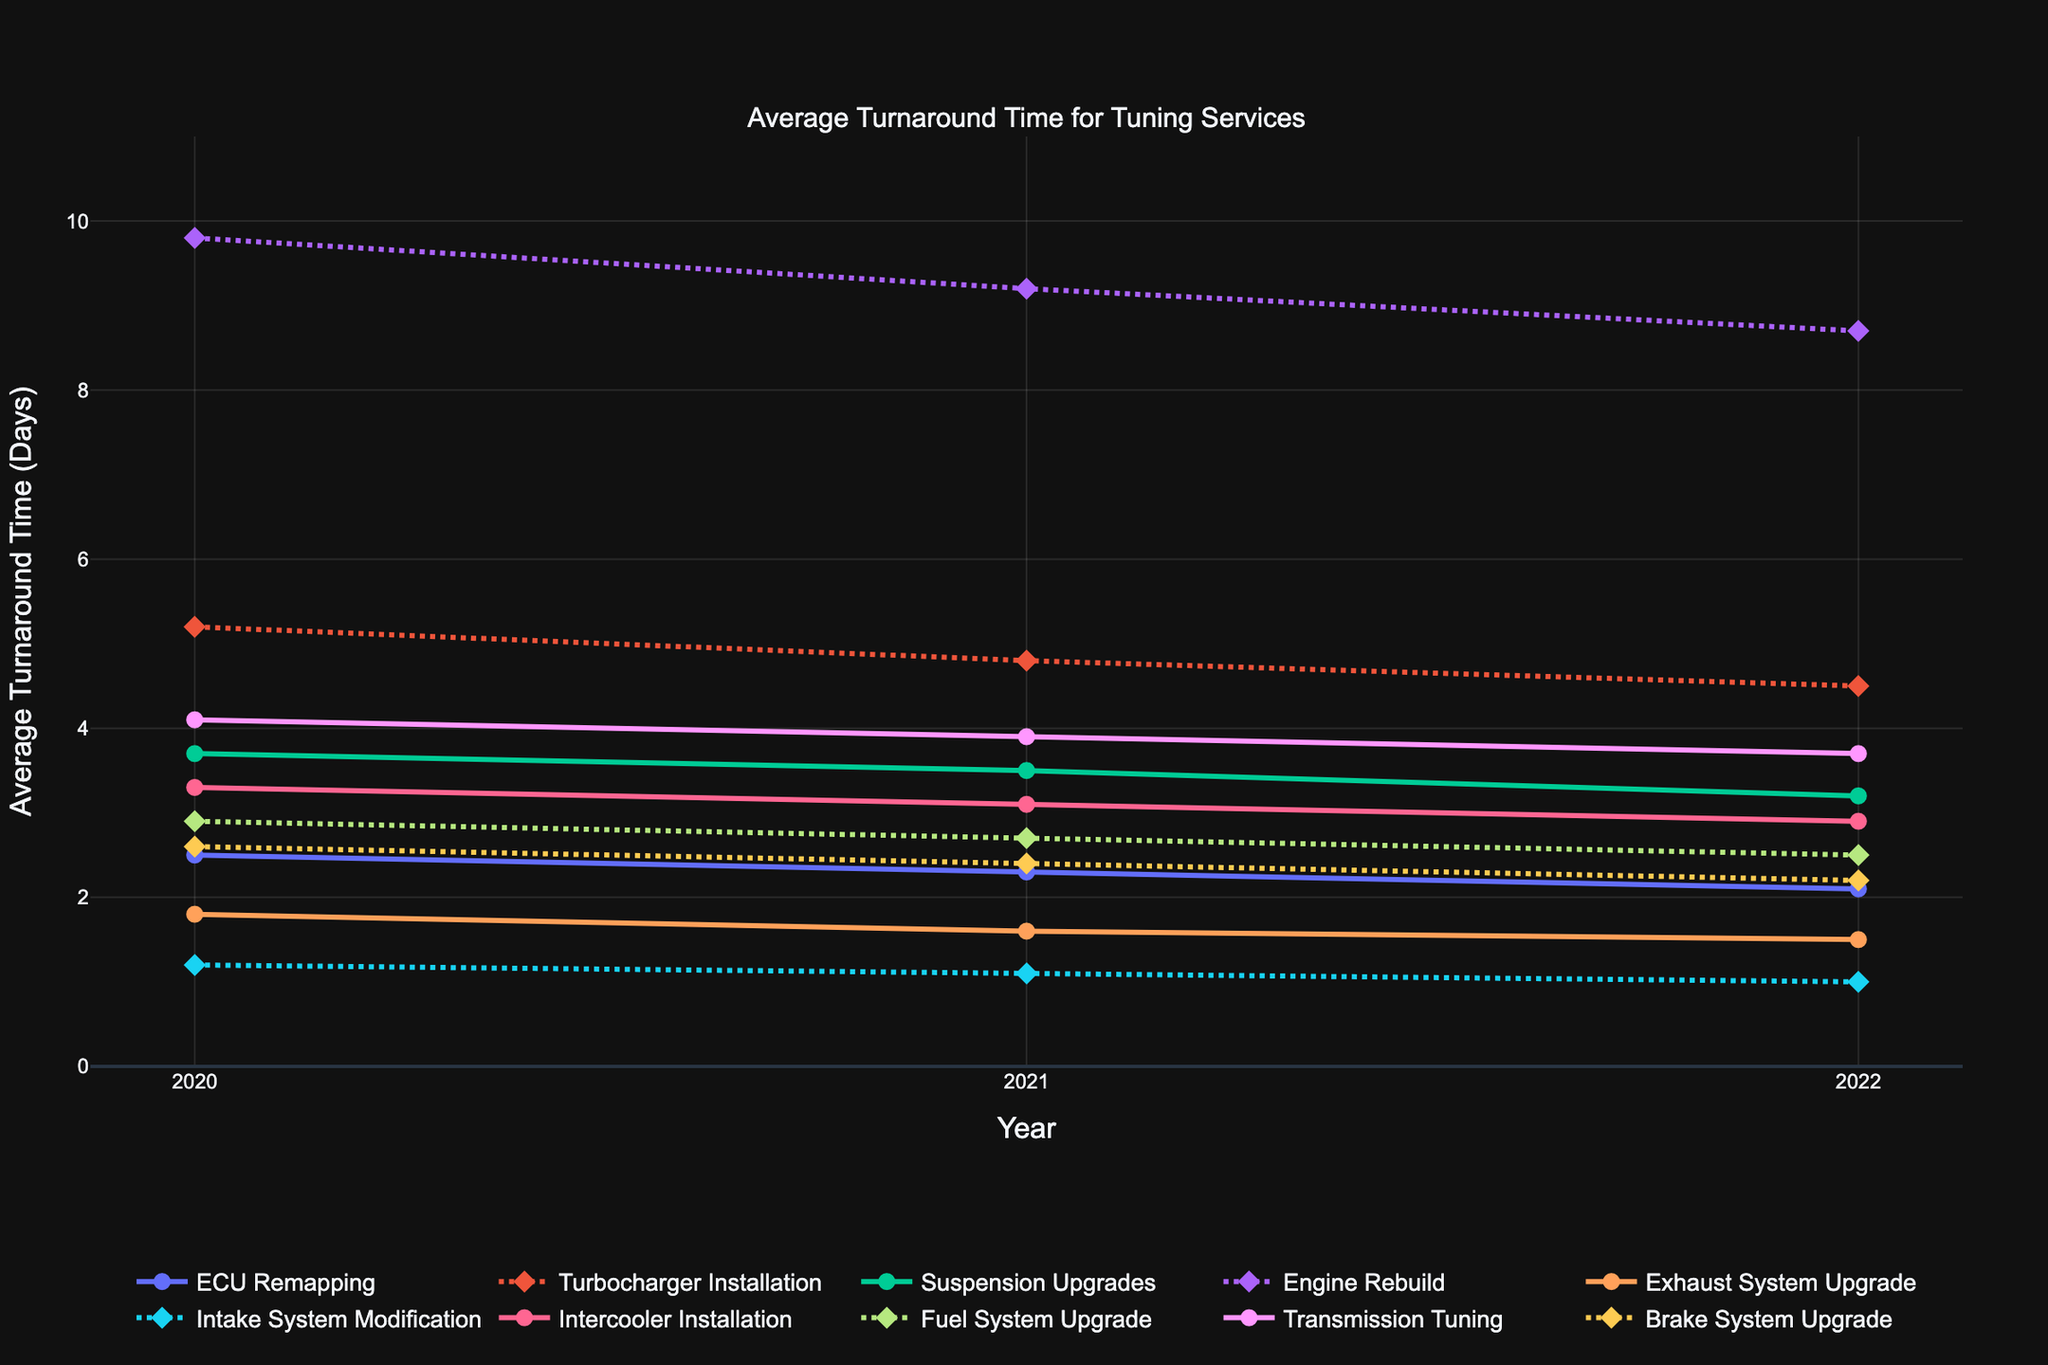Which service had the largest reduction in average turnaround time from 2020 to 2022? To find this, calculate the reduction for each service by subtracting the 2022 figure from the 2020 figure. Then, identify the largest value. For ECU Remapping, it is 2.5 - 2.1 = 0.4. For Turbocharger Installation, it is 5.2 - 4.5 = 0.7. For Suspension Upgrades, it is 3.7 - 3.2 = 0.5. For Engine Rebuild, it is 9.8 - 8.7 = 1.1. For Exhaust System Upgrade, it is 1.8 - 1.5 = 0.3. For Intake System Modification, it is 1.2 - 1.0 = 0.2. For Intercooler Installation, it is 3.3 - 2.9 = 0.4. For Fuel System Upgrade, it is 2.9 - 2.5 = 0.4. For Transmission Tuning, it is 4.1 - 3.7 = 0.4. For Brake System Upgrade, it is 2.6 - 2.2 = 0.4. So, the largest reduction is for Engine Rebuild (1.1).
Answer: Engine Rebuild Which service had the shortest average turnaround time in 2022? To answer this, look at the 2022 column and identify the smallest value. The values are: ECU Remapping (2.1), Turbocharger Installation (4.5), Suspension Upgrades (3.2), Engine Rebuild (8.7), Exhaust System Upgrade (1.5), Intake System Modification (1.0), Intercooler Installation (2.9), Fuel System Upgrade (2.5), Transmission Tuning (3.7), Brake System Upgrade (2.2). The smallest value is 1.0, corresponding to Intake System Modification.
Answer: Intake System Modification Which service shows a consistent yearly decrease in average turnaround time from 2020 to 2022? To determine this, check for each service whether the turnaround time decreases from 2020 to 2021 and again from 2021 to 2022. ECU Remapping: 2.5 -> 2.3 -> 2.1 (yes), Turbocharger Installation: 5.2 -> 4.8 -> 4.5 (yes), Suspension Upgrades: 3.7 -> 3.5 -> 3.2 (yes), Engine Rebuild: 9.8 -> 9.2 -> 8.7 (yes), Exhaust System Upgrade: 1.8 -> 1.6 -> 1.5 (yes), Intake System Modification: 1.2 -> 1.1 -> 1.0 (yes), Intercooler Installation: 3.3 -> 3.1 -> 2.9 (yes), Fuel System Upgrade: 2.9 -> 2.7 -> 2.5 (yes), Transmission Tuning: 4.1 -> 3.9 -> 3.7 (yes), Brake System Upgrade: 2.6 -> 2.4 -> 2.2 (yes). All services show a consistent decrease.
Answer: All services By how many days did the average turnaround time for Turbocharger Installation decrease from 2020 to 2021? To find this, subtract the 2021 value from the 2020 value for Turbocharger Installation. The values are 5.2 days in 2020 and 4.8 days in 2021. The decrease is 5.2 - 4.8 = 0.4 days.
Answer: 0.4 days What's the average turnaround time for Suspension Upgrades over the three years? Add the average turnaround times for 2020, 2021, and 2022, and then divide by 3. Suspension Upgrades: (3.7 + 3.5 + 3.2) / 3 = 10.4 / 3 = 3.47 days (rounded to two decimal places).
Answer: 3.47 days Which two services had the same number of days decrease in turnaround time from 2021 to 2022? Compare the difference in turnaround times for each service from 2021 to 2022. ECU Remapping: 2.3 - 2.1 = 0.2, Turbocharger Installation: 4.8 - 4.5 = 0.3, Suspension Upgrades: 3.5 - 3.2 = 0.3, Engine Rebuild: 9.2 - 8.7 = 0.5, Exhaust System Upgrade: 1.6 - 1.5 = 0.1, Intake System Modification: 1.1 - 1.0 = 0.1, Intercooler Installation: 3.1 - 2.9 = 0.2, Fuel System Upgrade: 2.7 - 2.5 = 0.2, Transmission Tuning: 3.9 - 3.7 = 0.2, Brake System Upgrade: 2.4 - 2.2 = 0.2. Several pairs have the same decrease: ECU Remapping and Intercooler Installation, between others.
Answer: ECU Remapping and Intercooler Installation 